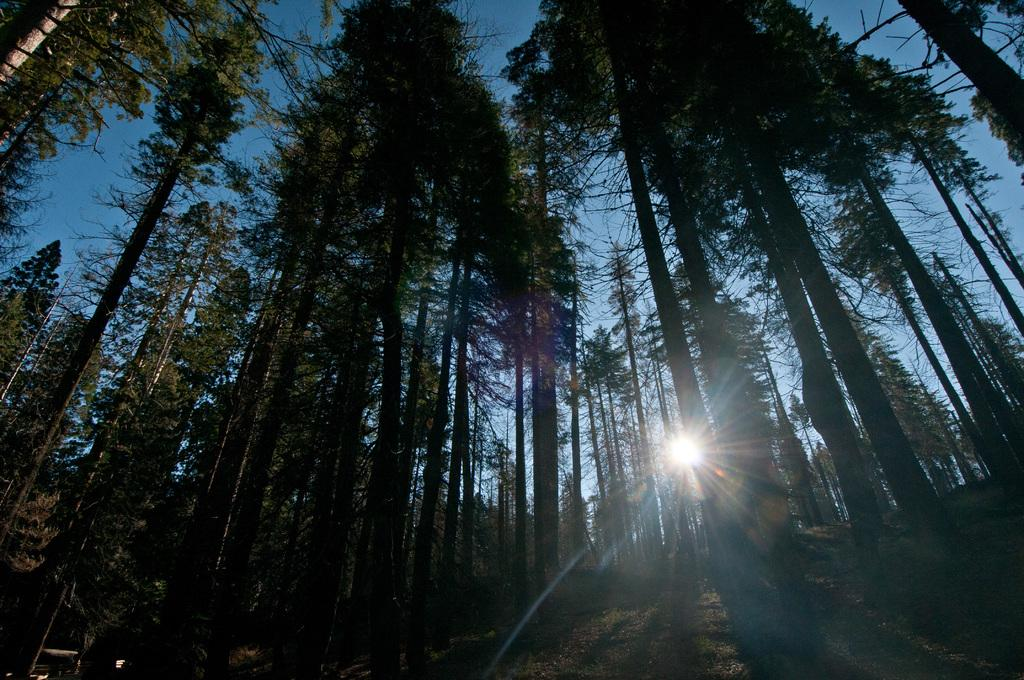What type of environment is depicted in the image? The image is taken in a wooded area. What natural features can be seen in the image? There are trees and grass in the image. What is the condition of the sky in the background of the image? The sun is shining in the sky in the background of the image. How many sparks can be seen coming from the trees in the image? There are no sparks present in the image; it features a wooded area with trees and grass. What color are the eyes of the animals in the image? There are no animals with visible eyes in the image; it only shows trees, grass, and a sunny sky. 